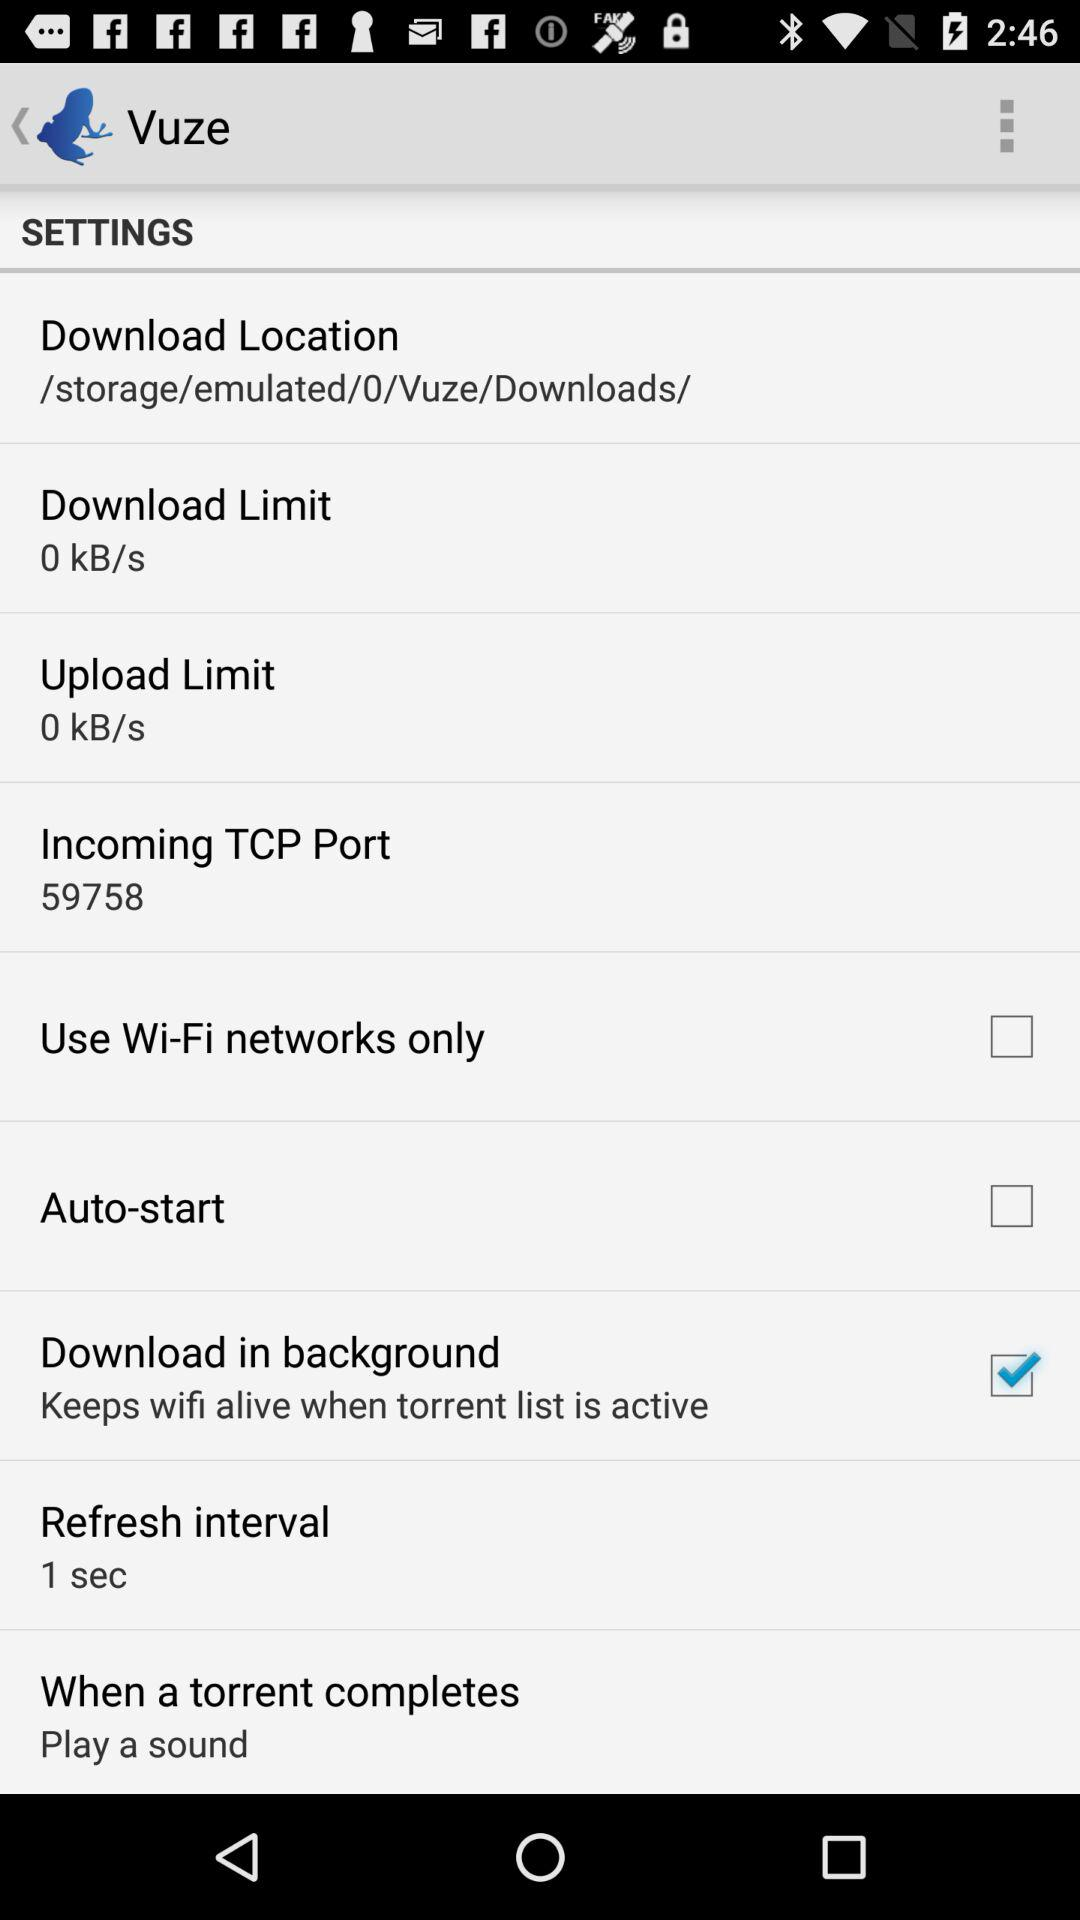What is the incoming TCP port? The incoming TCP port is 59758. 